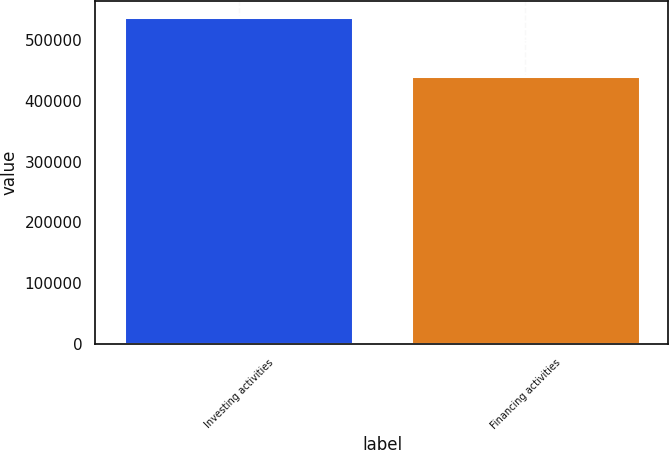Convert chart to OTSL. <chart><loc_0><loc_0><loc_500><loc_500><bar_chart><fcel>Investing activities<fcel>Financing activities<nl><fcel>537427<fcel>440863<nl></chart> 